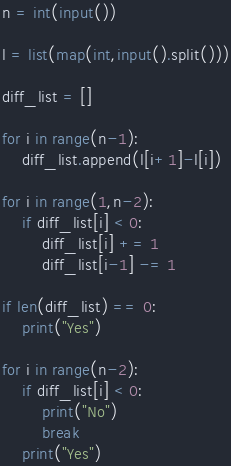Convert code to text. <code><loc_0><loc_0><loc_500><loc_500><_Python_>n = int(input())

l = list(map(int,input().split()))

diff_list = []

for i in range(n-1):
    diff_list.append(l[i+1]-l[i])
    
for i in range(1,n-2):
    if diff_list[i] < 0:
        diff_list[i] += 1
        diff_list[i-1] -= 1

if len(diff_list) == 0:
    print("Yes")

for i in range(n-2):
    if diff_list[i] < 0:
        print("No")
        break
    print("Yes")</code> 